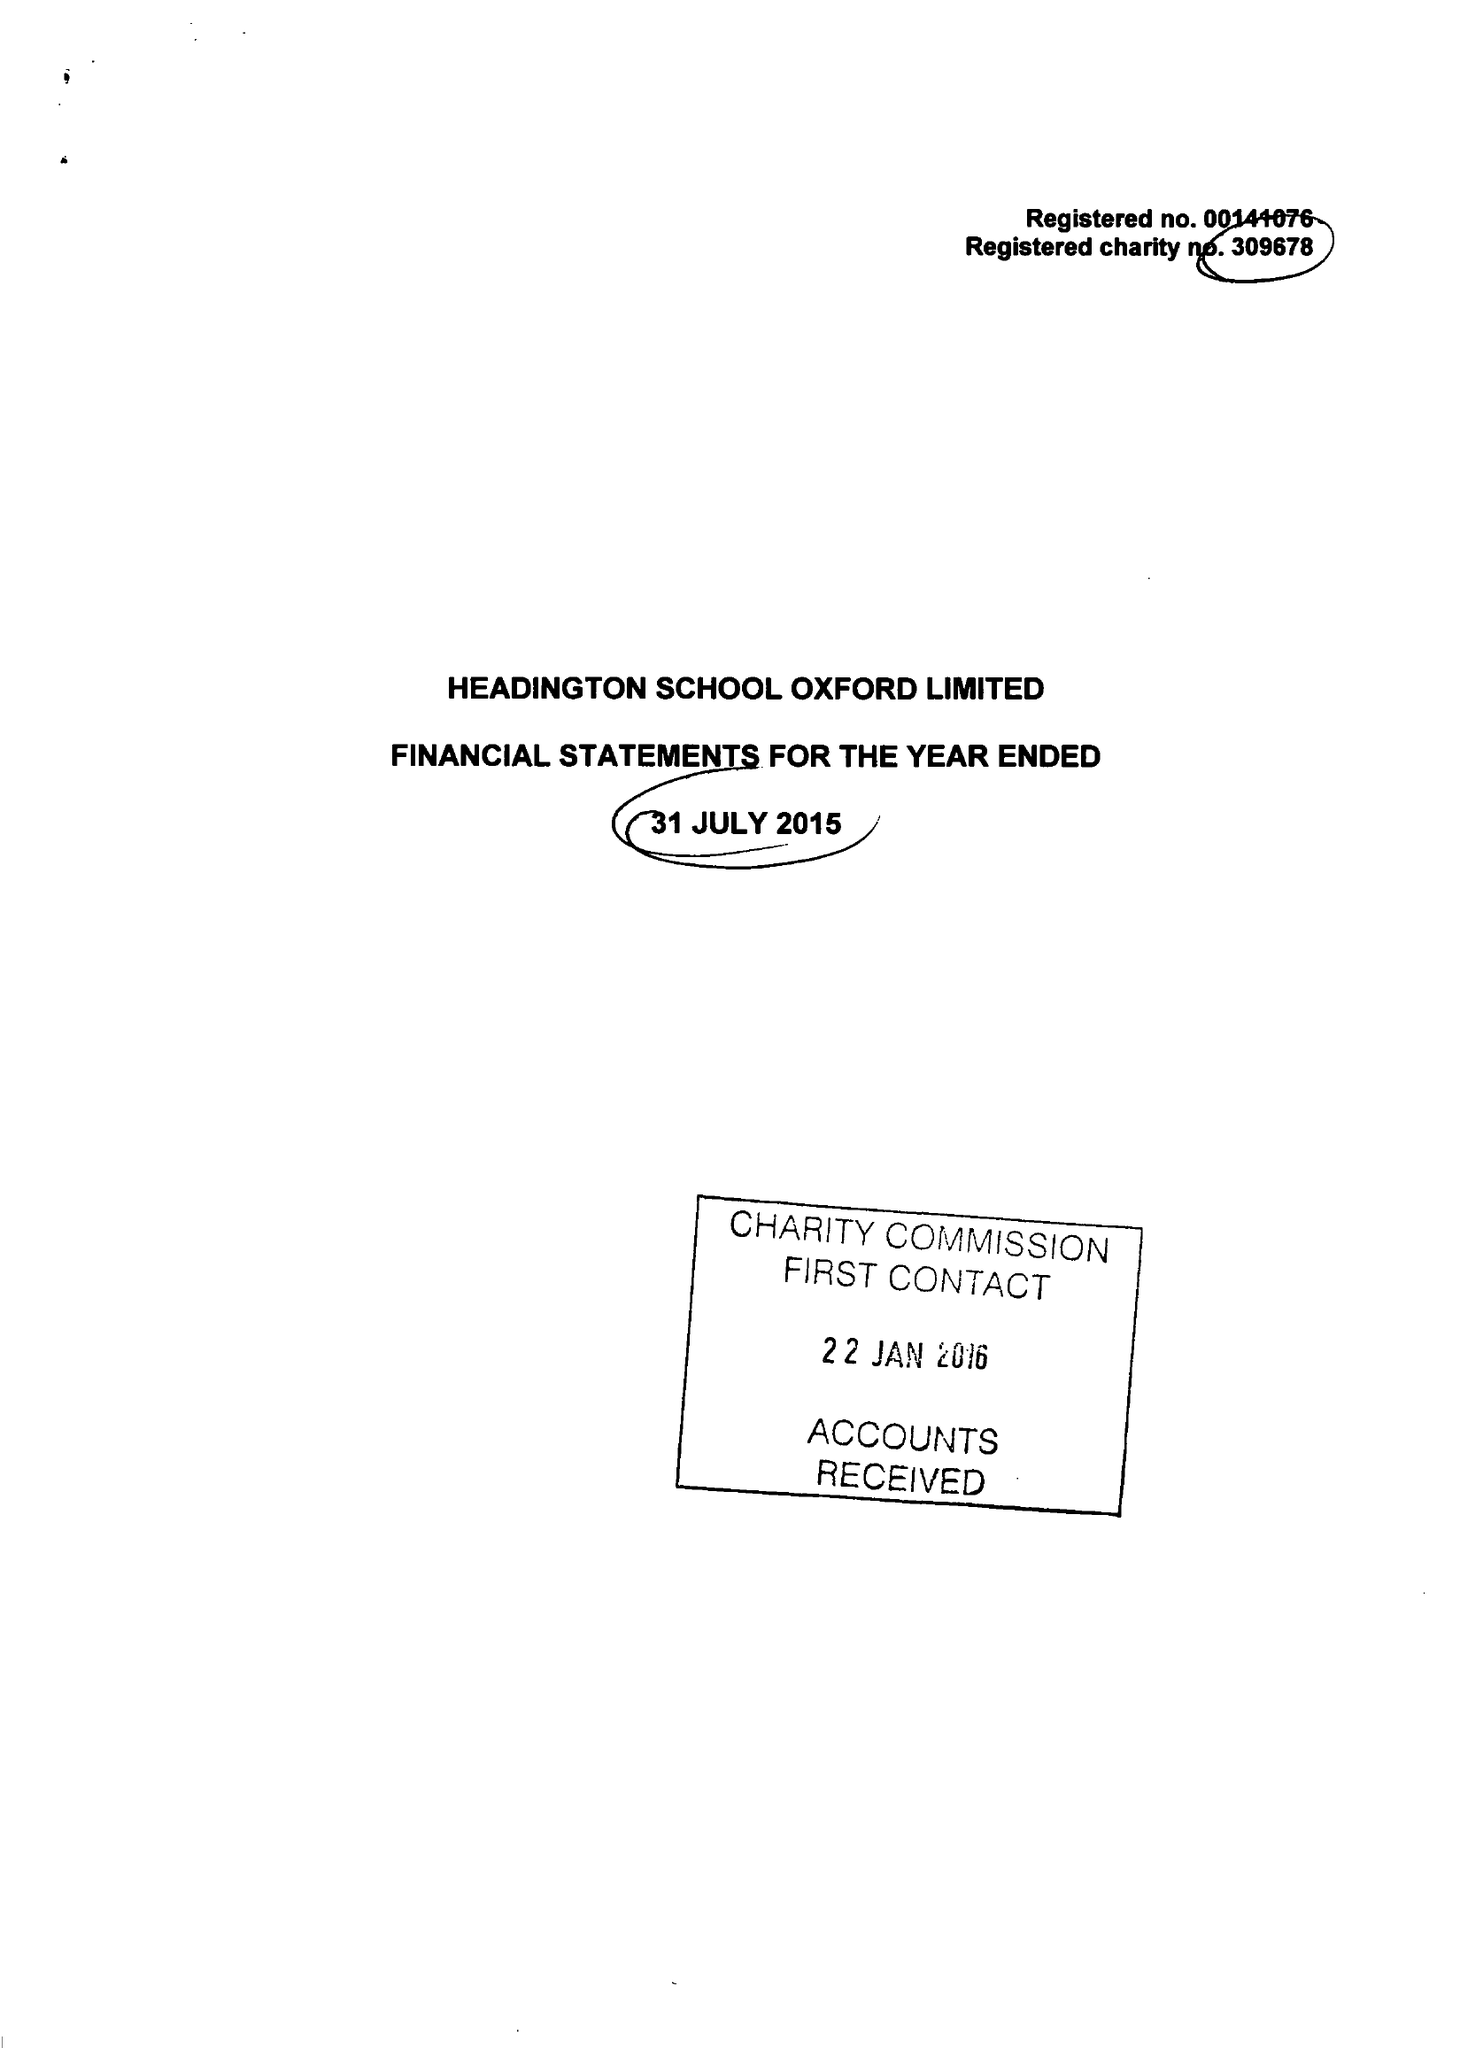What is the value for the address__post_town?
Answer the question using a single word or phrase. OXFORD 